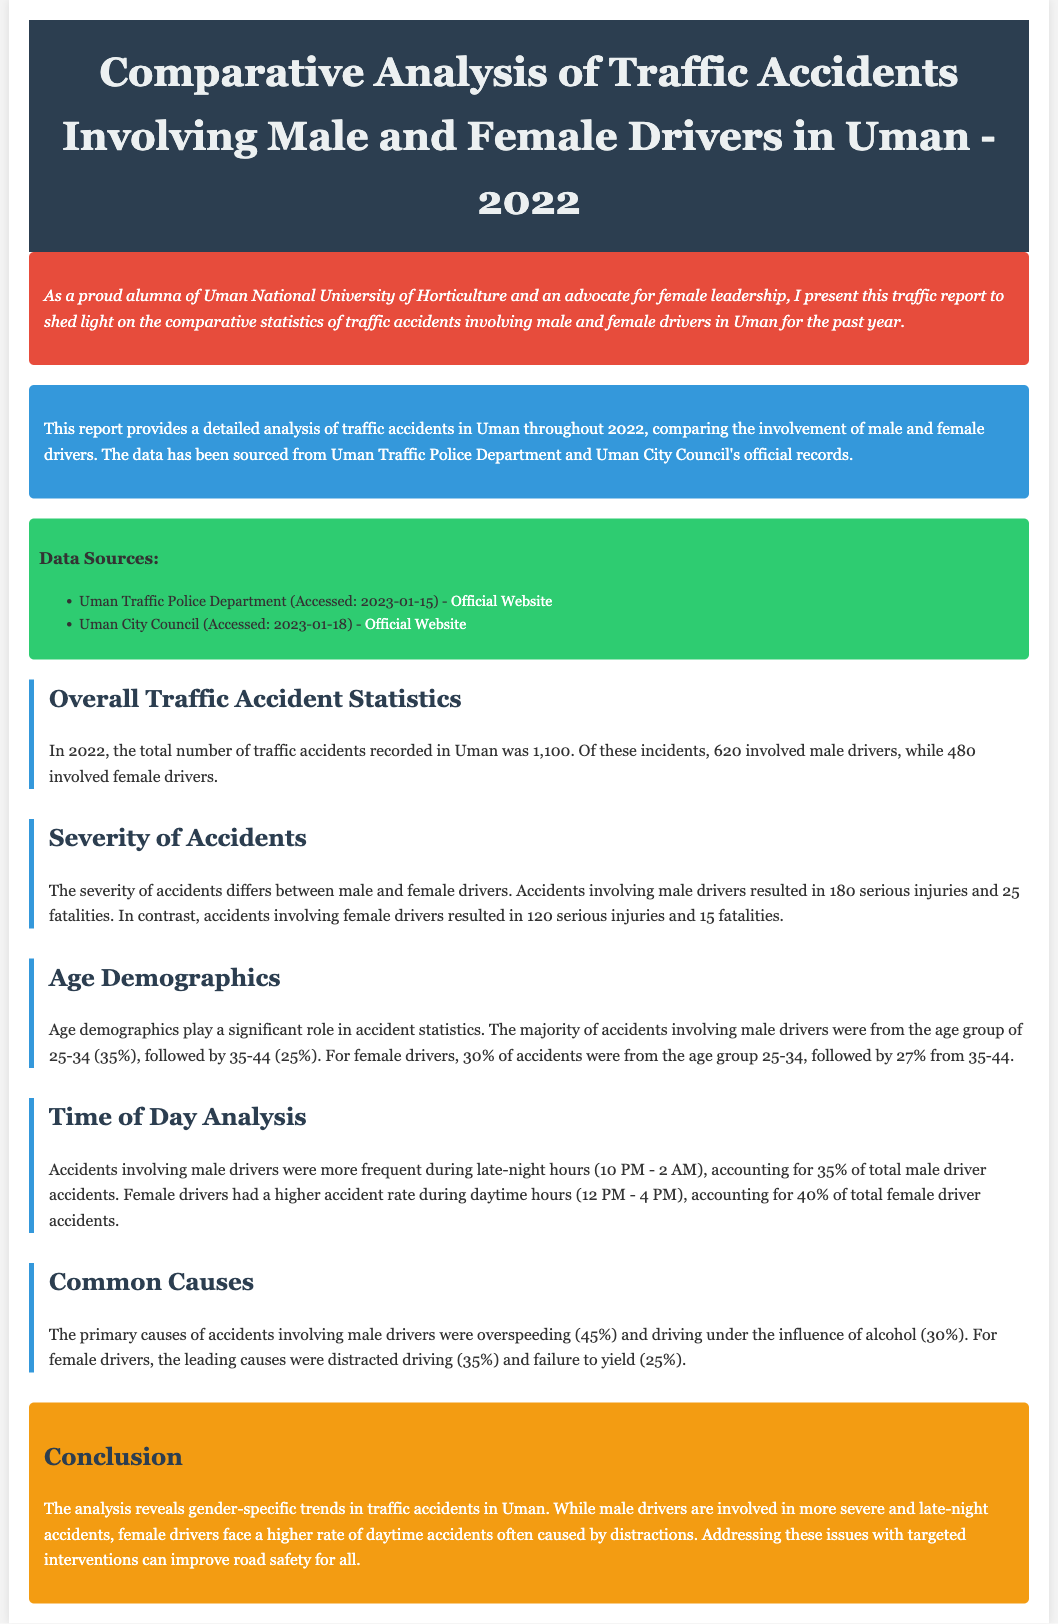What was the total number of traffic accidents in Uman in 2022? The total number of traffic accidents recorded in Uman was mentioned in the summary as 1,100.
Answer: 1,100 How many male drivers were involved in traffic accidents? The document states that 620 accidents involved male drivers.
Answer: 620 What are the leading causes of accidents for female drivers? The primary causes of accidents involving female drivers are outlined in the document as distracted driving and failure to yield.
Answer: Distracted driving and failure to yield Which age group had the highest percentage of accidents for male drivers? The document specifies that the age group 25-34 accounted for 35% of accidents involving male drivers.
Answer: 25-34 How many serious injuries were reported for accidents involving female drivers? The severity of accidents for female drivers indicates that there were 120 serious injuries.
Answer: 120 During which hours do most male driver accidents occur? According to the time of day analysis, accidents involving male drivers were more frequent during late-night hours (10 PM - 2 AM).
Answer: Late-night hours (10 PM - 2 AM) What percentage of accidents involving female drivers occur during daytime hours? The document states that 40% of total female driver accidents occurred during daytime hours (12 PM - 4 PM).
Answer: 40% How many fatalities were recorded involving male drivers? The severity statistics indicate that there were 25 fatalities involving male drivers.
Answer: 25 What is emphasized in the conclusion regarding the trends in traffic accidents? The conclusion highlights that gender-specific trends reveal different patterns in traffic accidents involving male and female drivers.
Answer: Gender-specific trends 